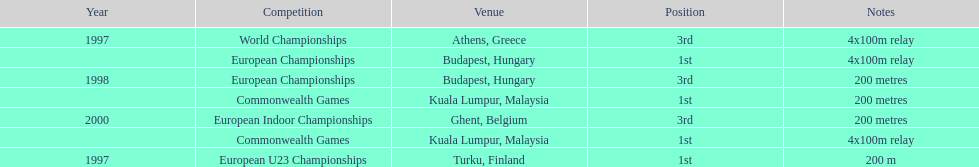In what year did england achieve the greatest success in the 200 meter? 1997. 